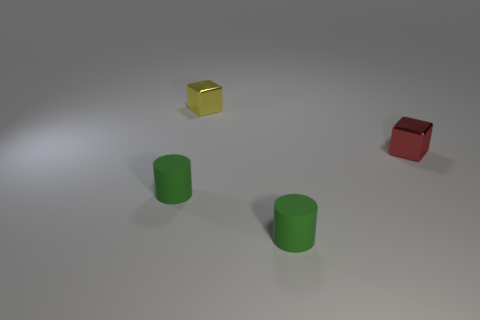Add 2 small yellow metal cubes. How many objects exist? 6 Add 2 small yellow cubes. How many small yellow cubes are left? 3 Add 3 green rubber cylinders. How many green rubber cylinders exist? 5 Subtract 0 yellow spheres. How many objects are left? 4 Subtract all large purple metallic blocks. Subtract all rubber things. How many objects are left? 2 